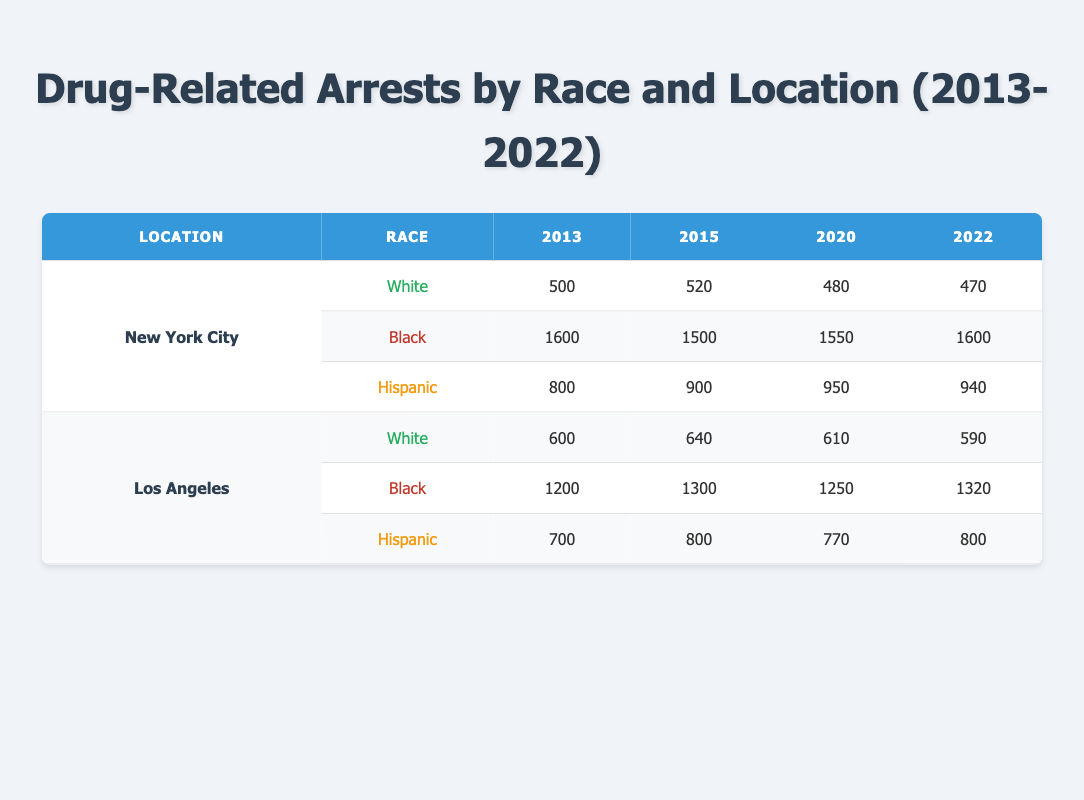What was the total number of drug-related arrests in New York City in 2013? For New York City in 2013, the total number of arrests can be calculated by adding the arrests across all races: 500 (White) + 1600 (Black) + 800 (Hispanic) = 2900.
Answer: 2900 Which race had the highest number of drug-related arrests in Los Angeles in 2020? In Los Angeles in 2020, the arrests by race were: 610 (White), 1250 (Black), and 770 (Hispanic). Comparing these figures, Black had the highest number of arrests at 1250.
Answer: Black How many Hispanic drug-related arrests were there in New York City in 2022? The table indicates that in New York City in 2022, the number of Hispanic drug-related arrests is highlighted as 940.
Answer: 940 What is the difference in drug-related arrests for Black individuals in New York City between 2013 and 2022? To find the difference, subtract the number of arrests in 2013 from those in 2022: 1600 (2022) - 1600 (2013) = 0. Therefore, the difference is 0.
Answer: 0 What was the trend in White drug-related arrests in Los Angeles from 2013 to 2022? The counts for White arrests in Los Angeles are as follows: 600 (2013), 640 (2015), 610 (2020), and 590 (2022). This shows an initial increase in 2015 followed by a decrease in subsequent years, indicating a downward trend overall.
Answer: Downward trend Did the total number of arrests for Hispanics increase or decrease in New York City from 2013 to 2022? In New York City, the arrests for Hispanics were: 800 in 2013 and 940 in 2022. Since 940 is greater than 800, this indicates an increase.
Answer: Increase What is the average number of drug-related arrests for Black individuals in Los Angeles from 2013 to 2022? The totals for Black arrests in Los Angeles are: 1200 (2013), 1300 (2015), 1250 (2020), and 1320 (2022). The sum of these arrests is 1200 + 1300 + 1250 + 1320 = 5070. Since there are 4 data points, the average is 5070/4 = 1267.5.
Answer: 1267.5 Which location had the highest total drug-related arrests for Hispanic individuals across all years? For Hispanic arrests, New York City has: 800 (2013), 900 (2015), 950 (2020), and 940 (2022); totaling 3590. Los Angeles has: 700 (2013), 800 (2015), 770 (2020), and 800 (2022); totaling 3070. Thus, New York City had more Hispanic arrests, totaling 3590 compared to Los Angeles's 3070.
Answer: New York City What was the change in total drug-related arrests for White individuals in New York City between 2015 and 2020? The total during those years was 520 (2015) and 480 (2020). To determine the change: 480 - 520 = -40, indicating a decrease of 40 arrests.
Answer: Decrease of 40 Is it true that the total number of drug-related arrests for Black individuals in New York City was higher than for White individuals every year from 2013 to 2022? Reviewing the data: Black arrests were consistently higher: 1600 > 500 (2013), 1500 > 520 (2015), 1550 > 480 (2020), and 1600 > 470 (2022). Thus, the statement is true for all years.
Answer: True 